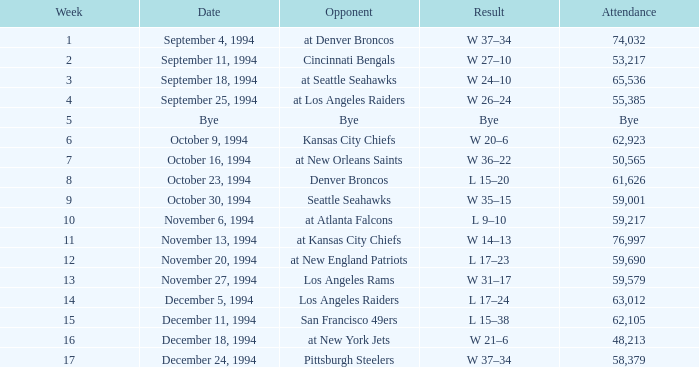On November 20, 1994, what was the result of the game? L 17–23. 